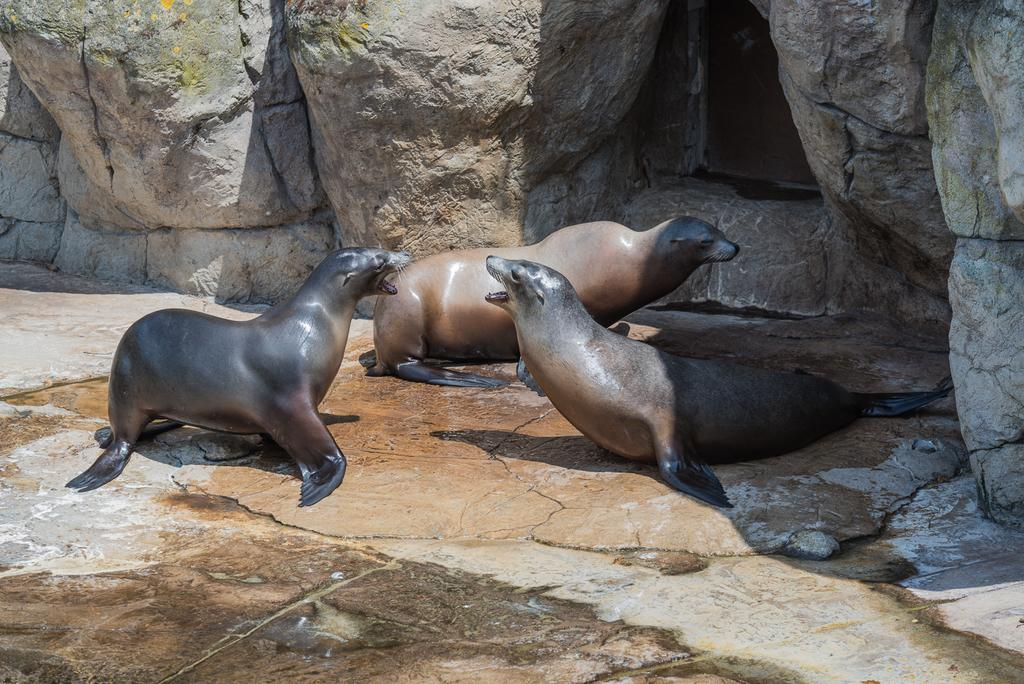What animals are present in the image? There are seals in the image. What is the background of the image? The seals are in front of a rock hill. Where is the rabbit hiding in the image? There is no rabbit present in the image; it only features seals in front of a rock hill. 